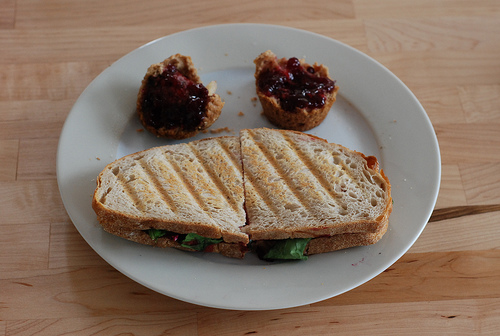What is the sandwich filling you can see in the image? The sandwich in the image seems to contain some leafy greens which could be lettuce or spinach, and possibly some slices of tomato, but the other contents are not clearly visible. 